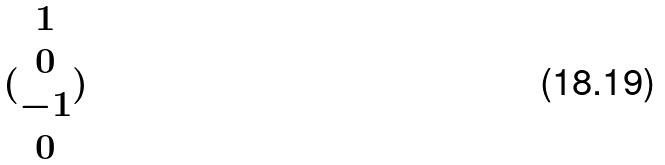Convert formula to latex. <formula><loc_0><loc_0><loc_500><loc_500>( \begin{matrix} 1 \\ 0 \\ - 1 \\ 0 \end{matrix} )</formula> 